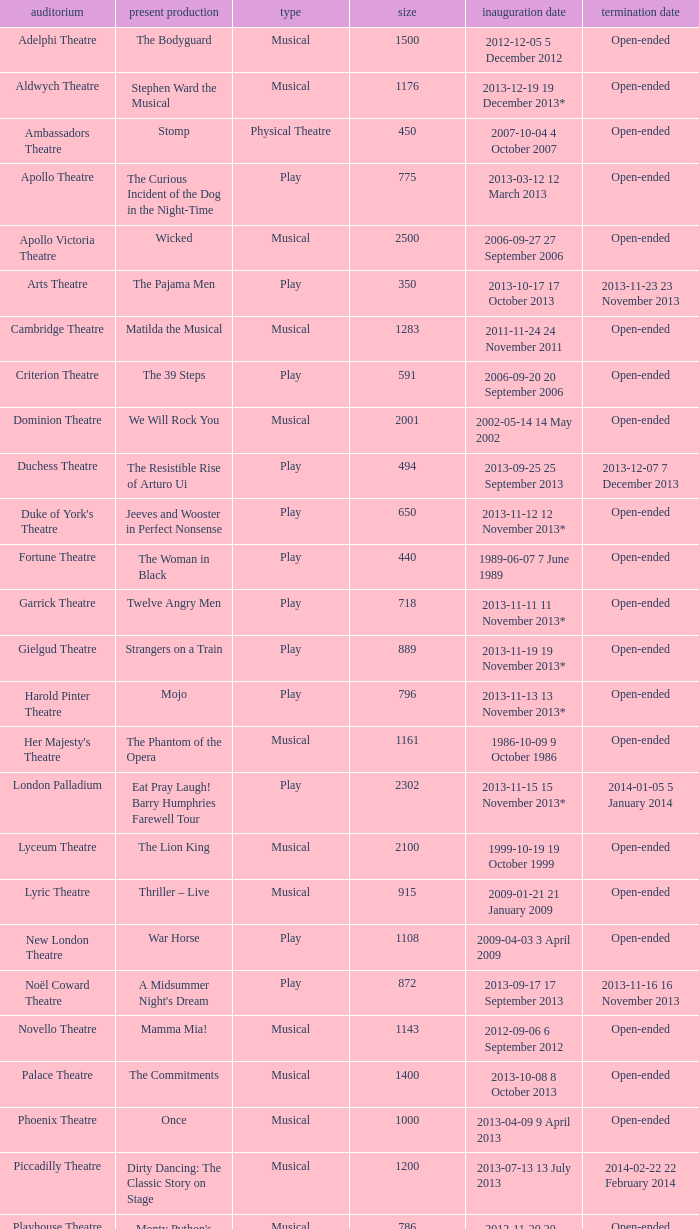What commencement date has a limit of 100? 2013-11-01 1 November 2013. Parse the full table. {'header': ['auditorium', 'present production', 'type', 'size', 'inauguration date', 'termination date'], 'rows': [['Adelphi Theatre', 'The Bodyguard', 'Musical', '1500', '2012-12-05 5 December 2012', 'Open-ended'], ['Aldwych Theatre', 'Stephen Ward the Musical', 'Musical', '1176', '2013-12-19 19 December 2013*', 'Open-ended'], ['Ambassadors Theatre', 'Stomp', 'Physical Theatre', '450', '2007-10-04 4 October 2007', 'Open-ended'], ['Apollo Theatre', 'The Curious Incident of the Dog in the Night-Time', 'Play', '775', '2013-03-12 12 March 2013', 'Open-ended'], ['Apollo Victoria Theatre', 'Wicked', 'Musical', '2500', '2006-09-27 27 September 2006', 'Open-ended'], ['Arts Theatre', 'The Pajama Men', 'Play', '350', '2013-10-17 17 October 2013', '2013-11-23 23 November 2013'], ['Cambridge Theatre', 'Matilda the Musical', 'Musical', '1283', '2011-11-24 24 November 2011', 'Open-ended'], ['Criterion Theatre', 'The 39 Steps', 'Play', '591', '2006-09-20 20 September 2006', 'Open-ended'], ['Dominion Theatre', 'We Will Rock You', 'Musical', '2001', '2002-05-14 14 May 2002', 'Open-ended'], ['Duchess Theatre', 'The Resistible Rise of Arturo Ui', 'Play', '494', '2013-09-25 25 September 2013', '2013-12-07 7 December 2013'], ["Duke of York's Theatre", 'Jeeves and Wooster in Perfect Nonsense', 'Play', '650', '2013-11-12 12 November 2013*', 'Open-ended'], ['Fortune Theatre', 'The Woman in Black', 'Play', '440', '1989-06-07 7 June 1989', 'Open-ended'], ['Garrick Theatre', 'Twelve Angry Men', 'Play', '718', '2013-11-11 11 November 2013*', 'Open-ended'], ['Gielgud Theatre', 'Strangers on a Train', 'Play', '889', '2013-11-19 19 November 2013*', 'Open-ended'], ['Harold Pinter Theatre', 'Mojo', 'Play', '796', '2013-11-13 13 November 2013*', 'Open-ended'], ["Her Majesty's Theatre", 'The Phantom of the Opera', 'Musical', '1161', '1986-10-09 9 October 1986', 'Open-ended'], ['London Palladium', 'Eat Pray Laugh! Barry Humphries Farewell Tour', 'Play', '2302', '2013-11-15 15 November 2013*', '2014-01-05 5 January 2014'], ['Lyceum Theatre', 'The Lion King', 'Musical', '2100', '1999-10-19 19 October 1999', 'Open-ended'], ['Lyric Theatre', 'Thriller – Live', 'Musical', '915', '2009-01-21 21 January 2009', 'Open-ended'], ['New London Theatre', 'War Horse', 'Play', '1108', '2009-04-03 3 April 2009', 'Open-ended'], ['Noël Coward Theatre', "A Midsummer Night's Dream", 'Play', '872', '2013-09-17 17 September 2013', '2013-11-16 16 November 2013'], ['Novello Theatre', 'Mamma Mia!', 'Musical', '1143', '2012-09-06 6 September 2012', 'Open-ended'], ['Palace Theatre', 'The Commitments', 'Musical', '1400', '2013-10-08 8 October 2013', 'Open-ended'], ['Phoenix Theatre', 'Once', 'Musical', '1000', '2013-04-09 9 April 2013', 'Open-ended'], ['Piccadilly Theatre', 'Dirty Dancing: The Classic Story on Stage', 'Musical', '1200', '2013-07-13 13 July 2013', '2014-02-22 22 February 2014'], ['Playhouse Theatre', "Monty Python's Spamalot", 'Musical', '786', '2012-11-20 20 November 2012', 'Open-ended'], ['Prince Edward Theatre', 'Jersey Boys', 'Musical', '1618', '2008-03-18 18 March 2008', '2014-03-09 9 March 2014'], ['Prince of Wales Theatre', 'The Book of Mormon', 'Musical', '1160', '2013-03-21 21 March 2013', 'Open-ended'], ["Queen's Theatre", 'Les Misérables', 'Musical', '1099', '2004-04-12 12 April 2004', 'Open-ended'], ['Savoy Theatre', 'Let It Be', 'Musical', '1158', '2013-02-01 1 February 2013', 'Open-ended'], ['Shaftesbury Theatre', 'From Here to Eternity the Musical', 'Musical', '1400', '2013-10-23 23 October 2013', 'Open-ended'], ['St. James Theatre', 'Scenes from a Marriage', 'Play', '312', '2013-09-11 11 September 2013', '2013-11-9 9 November 2013'], ["St Martin's Theatre", 'The Mousetrap', 'Play', '550', '1974-03-25 25 March 1974', 'Open-ended'], ['Theatre Royal, Haymarket', 'One Man, Two Guvnors', 'Play', '888', '2012-03-02 2 March 2012', '2013-03-01 1 March 2014'], ['Theatre Royal, Drury Lane', 'Charlie and the Chocolate Factory the Musical', 'Musical', '2220', '2013-06-25 25 June 2013', 'Open-ended'], ['Trafalgar Studios 1', 'The Pride', 'Play', '380', '2013-08-13 13 August 2013', '2013-11-23 23 November 2013'], ['Trafalgar Studios 2', 'Mrs. Lowry and Son', 'Play', '100', '2013-11-01 1 November 2013', '2013-11-23 23 November 2013'], ['Vaudeville Theatre', 'The Ladykillers', 'Play', '681', '2013-07-09 9 July 2013', '2013-11-16 16 November 2013'], ['Victoria Palace Theatre', 'Billy Elliot the Musical', 'Musical', '1517', '2005-05-11 11 May 2005', 'Open-ended'], ["Wyndham's Theatre", 'Barking in Essex', 'Play', '750', '2013-09-16 16 September 2013', '2014-01-04 4 January 2014']]} 